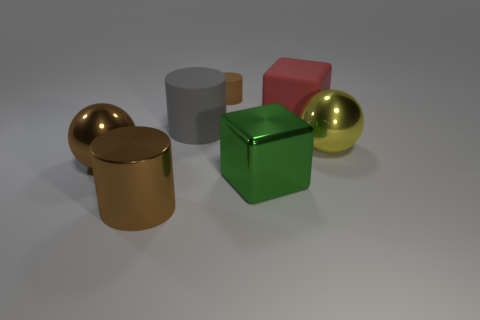How many metallic things are blue things or red blocks?
Your answer should be very brief. 0. What shape is the yellow object that is the same size as the green metallic cube?
Provide a short and direct response. Sphere. How many objects are big things that are left of the green metallic cube or brown things that are behind the brown metal cylinder?
Keep it short and to the point. 4. There is a red object that is the same size as the yellow metal sphere; what material is it?
Give a very brief answer. Rubber. What number of other things are made of the same material as the big yellow thing?
Offer a terse response. 3. Is the number of tiny brown cylinders in front of the big red object the same as the number of large gray matte things that are in front of the green object?
Offer a very short reply. Yes. How many brown objects are either shiny things or cylinders?
Your response must be concise. 3. Does the metal cylinder have the same color as the large metallic ball on the left side of the green thing?
Make the answer very short. Yes. How many other things are the same color as the shiny cylinder?
Provide a short and direct response. 2. Is the number of large yellow shiny things less than the number of large matte balls?
Your answer should be compact. No. 